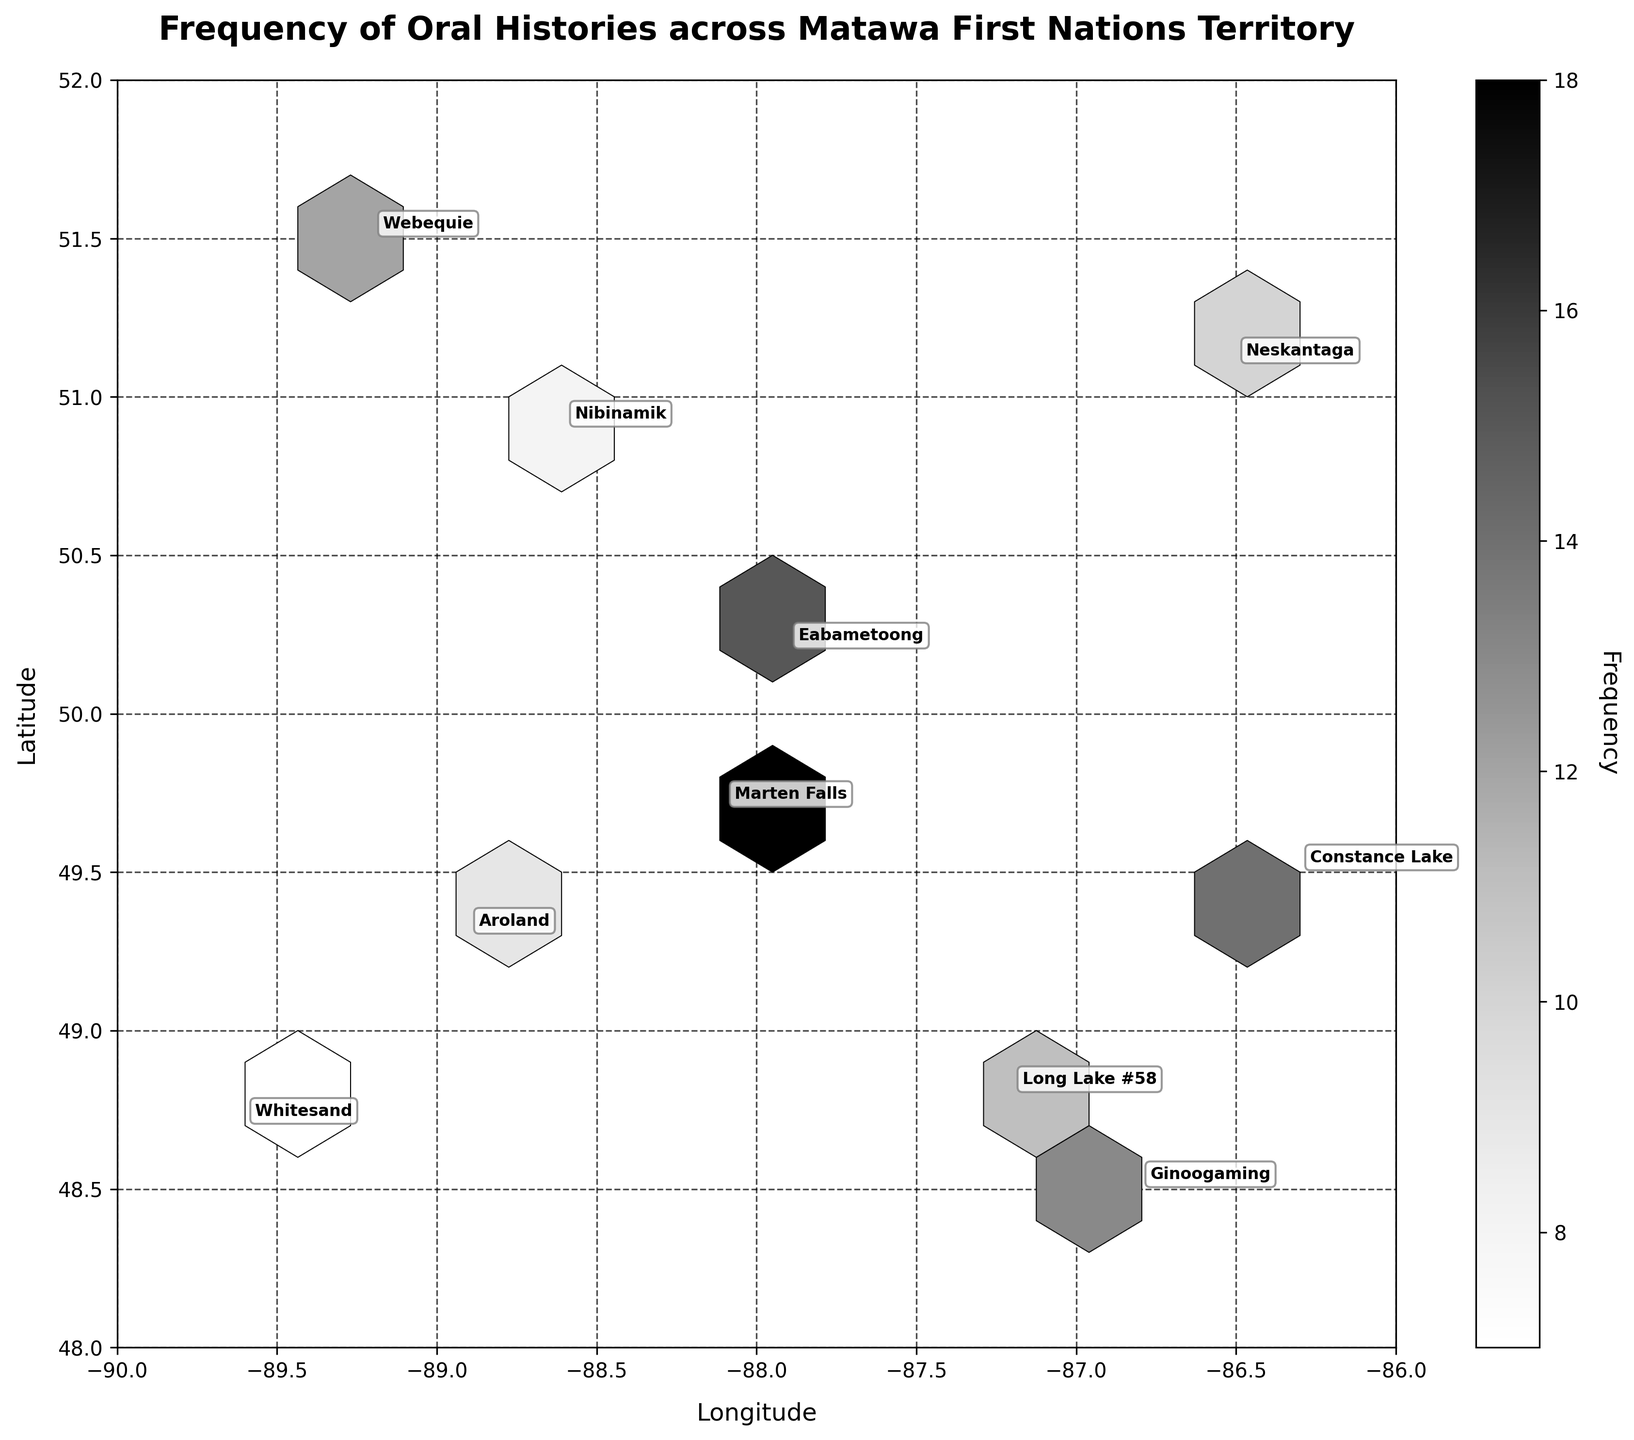What is the title of the hexbin plot? The title of the plot can be identified at the top of the figure where the main header is usually located. In this case, the title is “Frequency of Oral Histories across Matawa First Nations Territory.”
Answer: Frequency of Oral Histories across Matawa First Nations Territory What do the axes of the hexbin plot represent? By examining the labels on the horizontal and vertical lines of the figure, we can see that the x-axis represents “Longitude” and the y-axis represents “Latitude.”
Answer: Longitude and Latitude Which community has recorded the highest frequency of oral histories? By analyzing the hexbin plot, we can identify the community with the highest frequency by looking at the annotation with the highest value. In this figure, “Marten Falls” has a frequency of 18, which is the highest.
Answer: Marten Falls What is the range of frequencies depicted in the color bar? The color bar on the right-hand side of the plot shows the range of frequencies indicated by the shades it represents. By closely examining it, we see that the range is from 7 to 18.
Answer: 7 to 18 Which community is located furthest north? To find the community located furthest north, we need to look at the data point with the highest latitude value. In this case, “Webequie” at latitude 51.5 is the furthest north.
Answer: Webequie What is the average frequency of recorded oral histories across all communities? To find the average, we sum up the frequencies of all communities: 12 + 8 + 15 + 10 + 18 + 14 + 9 + 11 + 13 + 7 = 117. Then, divide by the number of communities, which is 10. The average is 117/10 = 11.7.
Answer: 11.7 Between Neskantaga and Ginoogaming, which one has a higher frequency of oral histories? By referring to the annotated data points, we see that Neskantaga has a frequency of 10 and Ginoogaming has a frequency of 13. Comparing the two, Ginoogaming has a higher frequency.
Answer: Ginoogaming Which two communities have the closest proximity in terms of latitude? To determine the closest proximity in terms of latitude, we compare the latitudes of neighboring communities. Nibinamik (latitude 50.9) and Neskantaga (latitude 51.1) are the closest, with a difference of only 0.2 degrees.
Answer: Nibinamik and Neskantaga What is the frequency of oral histories recorded for the community of Whitesand? Looking at the annotation labeled "Whitesand" on the hexbin plot, we can find the frequency directly next to it. For the community of Whitesand, the frequency is 7.
Answer: 7 